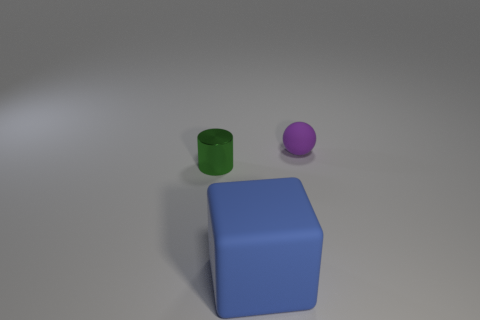Add 3 small metallic things. How many objects exist? 6 Subtract all cylinders. How many objects are left? 2 Subtract 1 purple spheres. How many objects are left? 2 Subtract all large cylinders. Subtract all blue matte objects. How many objects are left? 2 Add 3 matte cubes. How many matte cubes are left? 4 Add 1 matte cubes. How many matte cubes exist? 2 